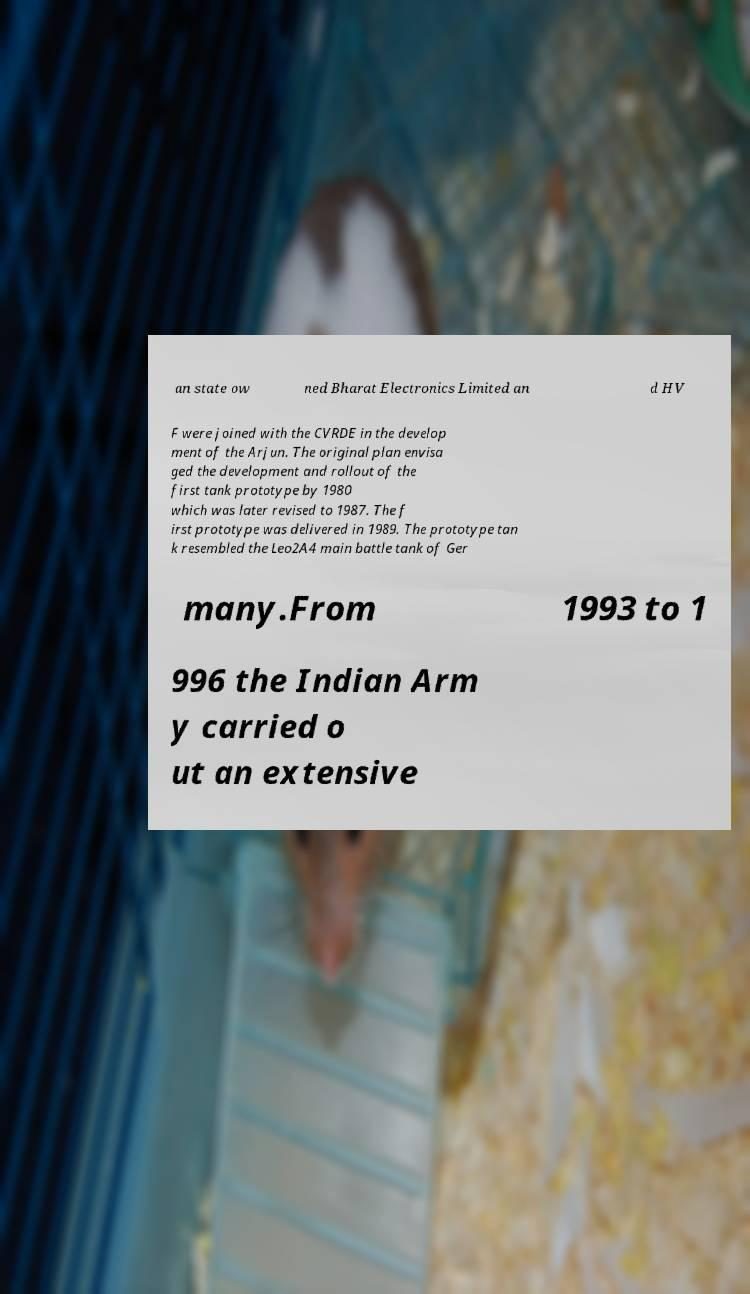What messages or text are displayed in this image? I need them in a readable, typed format. an state ow ned Bharat Electronics Limited an d HV F were joined with the CVRDE in the develop ment of the Arjun. The original plan envisa ged the development and rollout of the first tank prototype by 1980 which was later revised to 1987. The f irst prototype was delivered in 1989. The prototype tan k resembled the Leo2A4 main battle tank of Ger many.From 1993 to 1 996 the Indian Arm y carried o ut an extensive 